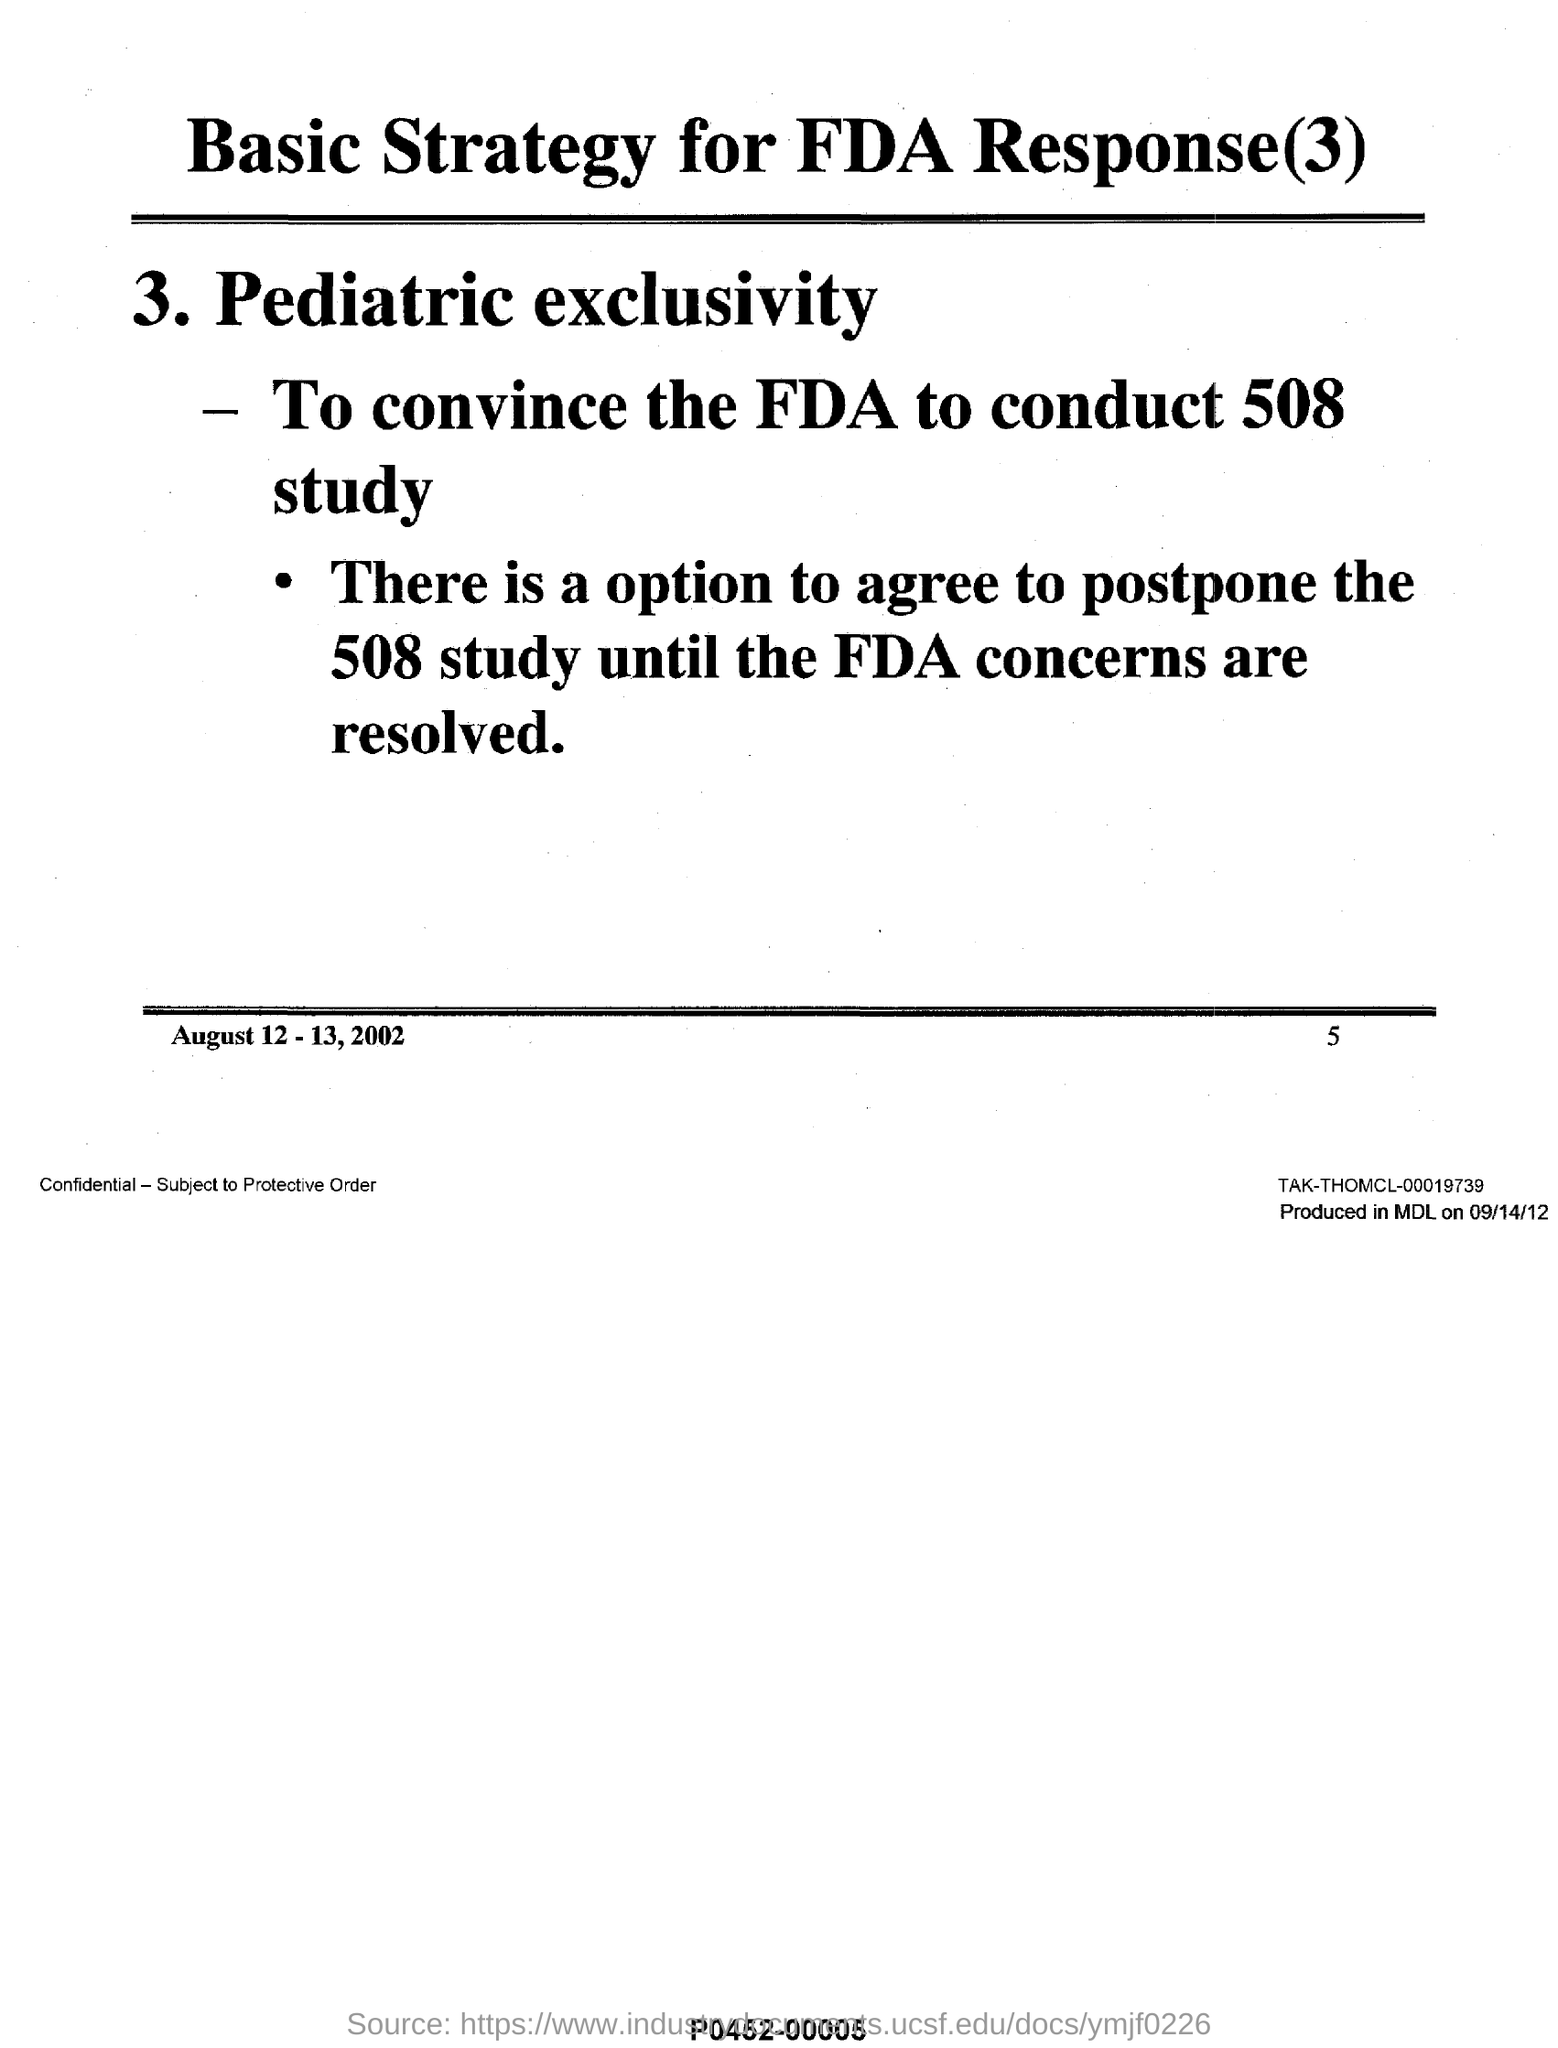What is the page no mentioned in this document?
Your response must be concise. 5. What is the date range mentioned in this document at the bottom?
Offer a very short reply. August 12-13, 2002. What is the title of this document?
Keep it short and to the point. Basic Strategy for FDA Response(3). 